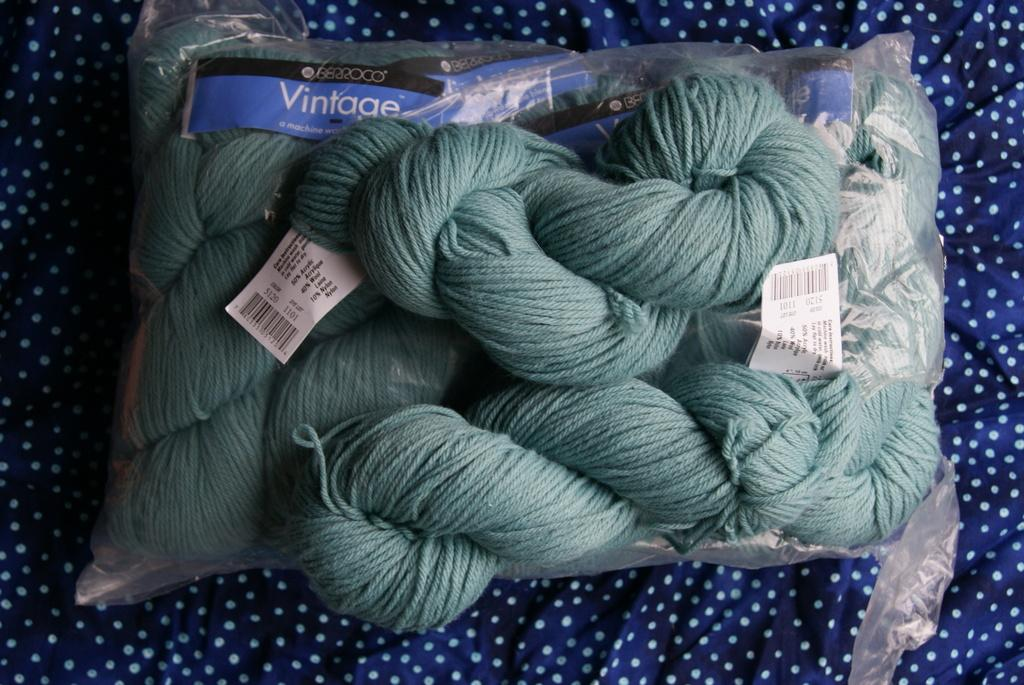What is covered by the woolen bundles in the image? The woolen bundles are covered by a cloth or cover. What type of material is used for the papers in the image? The papers in the image have text on them, suggesting they are made of paper or a similar material. How are the papers arranged in the image? The papers are placed on a cloth in the image. How many corks are visible in the image? There are no corks present in the image. What type of shape do the toes form in the image? There are no toes visible in the image. 